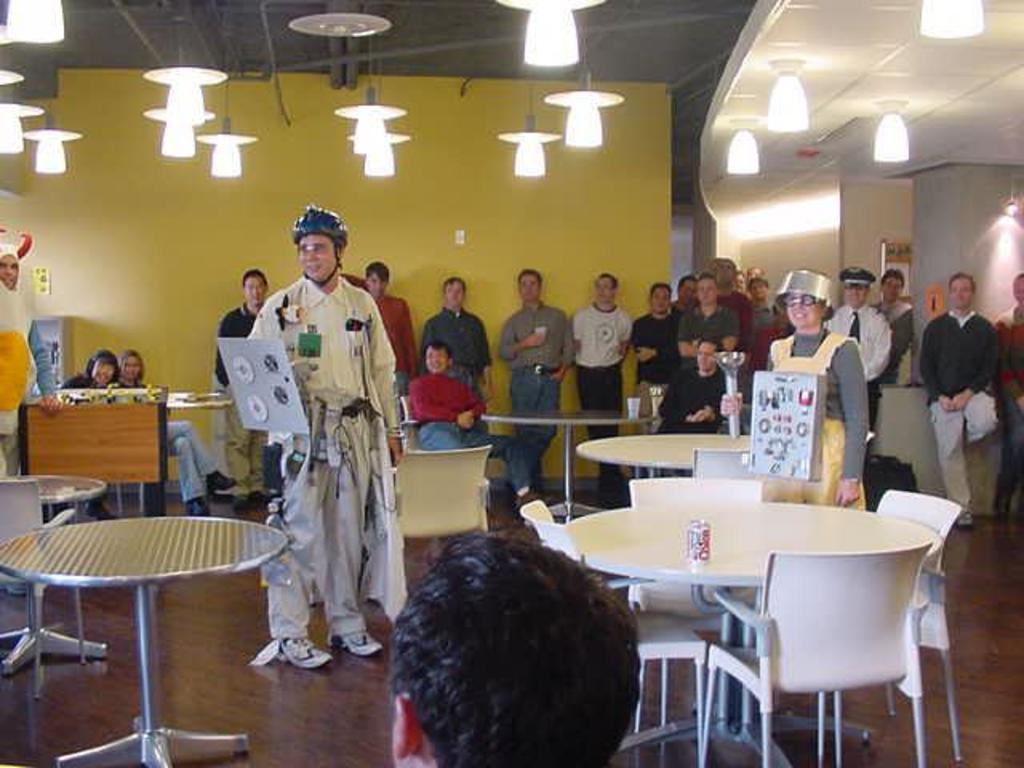Describe this image in one or two sentences. This image is taken inside the room. In the left side of the image there is table, chair and a person standing and sitting. In the right side of the image there is a pillar, chair and a person standing. In the middle of the image there is a person standing wearing a shoe and helmet. At the top of the image we can see ceiling, lights and at the background we can see a wall. 